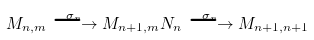<formula> <loc_0><loc_0><loc_500><loc_500>M _ { n , m } \stackrel { \sigma _ { n } } { \longrightarrow } M _ { n + 1 , m } { N } _ { n } \stackrel { \sigma _ { n } } { \longrightarrow } M _ { n + 1 , n + 1 }</formula> 